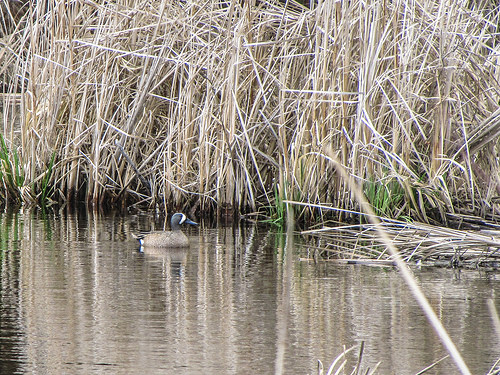<image>
Is there a duck next to the plants? Yes. The duck is positioned adjacent to the plants, located nearby in the same general area. Is there a duck above the water? No. The duck is not positioned above the water. The vertical arrangement shows a different relationship. 